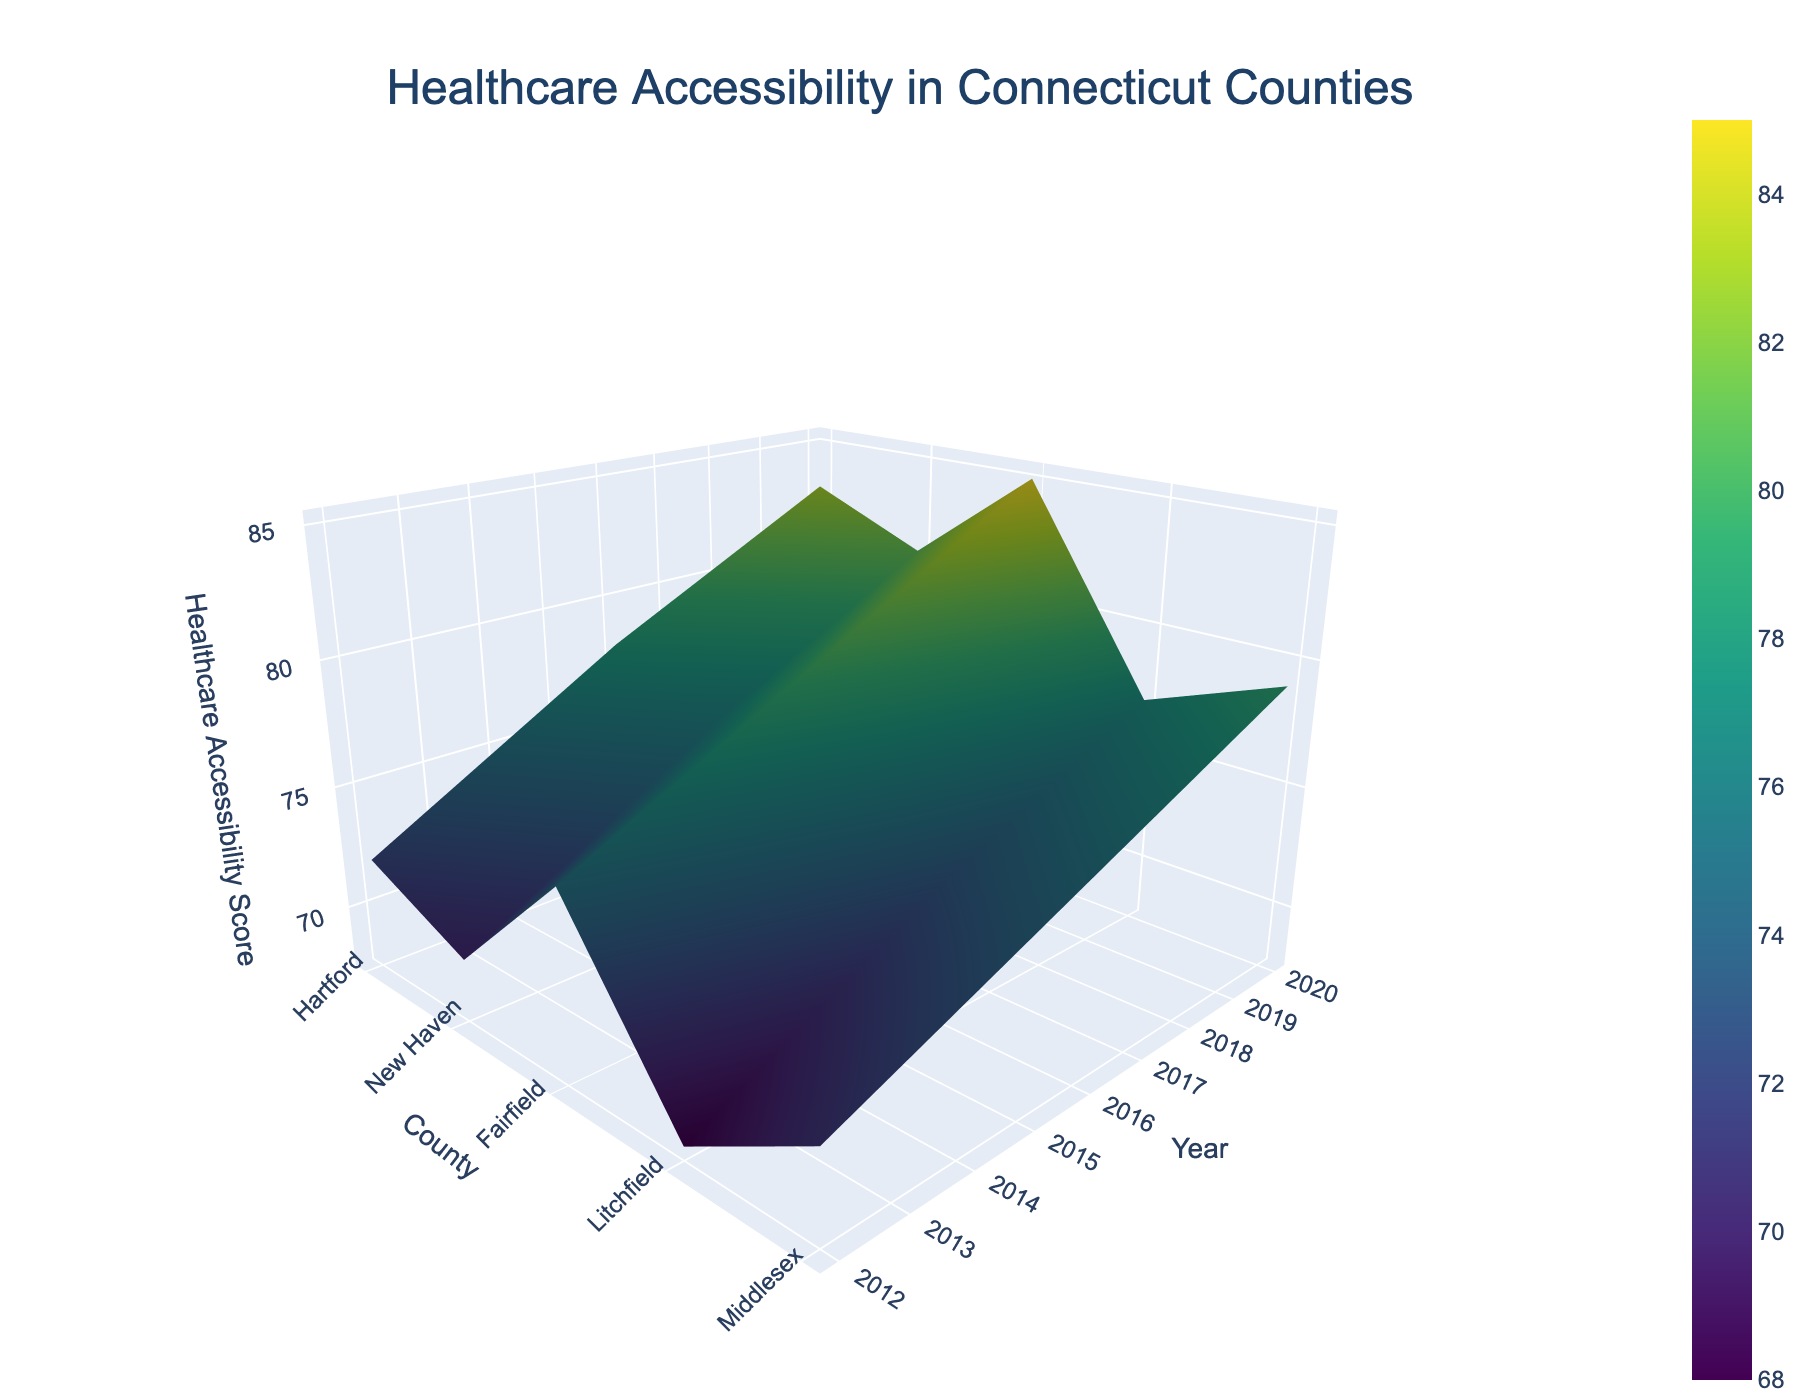What is the title of the figure? The title is displayed at the top of the figure in a large font size and is centered.
Answer: Healthcare Accessibility in Connecticut Counties How many counties are represented in the dataset over the years? To find the number of counties, count the distinct entries along the 'County' axis on the figure.
Answer: 5 In which year did Hartford County witness the highest healthcare accessibility score? Look along the Hartford County line on the surface and identify the year where the highest peak occurs in the z-axis.
Answer: 2020 What trend do you observe in the healthcare accessibility scores over the years for counties with high population density like Fairfield? By tracing the Fairfield County line over the z-axis from 2012 to 2020, you can observe whether the scores are increasing, decreasing, or fluctuating.
Answer: Increasing How does the healthcare accessibility score of Litchfield County in 2020 compare with its score in 2012? Look at the points where Litchfield intersects with 2012 and 2020 on the surface and compare the heights of these points.
Answer: Higher in 2020 Which year has the overall highest healthcare accessibility scores across all counties? Inspect the 3D surface to see where the peaks are most consistent across all counties, focusing on the year axis (y-axis).
Answer: 2020 Is there a notable difference in healthcare accessibility scores between counties with dense populations like New Haven and sparse populations like Litchfield in 2020? Compare the height of the New Haven and Litchfield points at the year 2020 on the z-axis.
Answer: New Haven higher Did the insurance coverage rate potentially influence the healthcare accessibility score trends over the years? While not directly viewable in the figure, reasoning includes considering if counties with higher insurance coverage rates had corresponding high scores in healthcare accessibility. Focus on the color gradation changes year-over-year in the curved lines for each county.
Answer: Yes What pattern do you notice in the healthcare accessibility scores for Middletown between 2012 and 2020? Trace the Middletown data points along the z-axis for each year and observe visually how the surface plot height changes.
Answer: Increasing What was the difference in the healthcare accessibility score between Fairfield and Hartford in 2016? Find both points on the surface for 2016 and calculate the height difference along the z-axis.
Answer: 2 